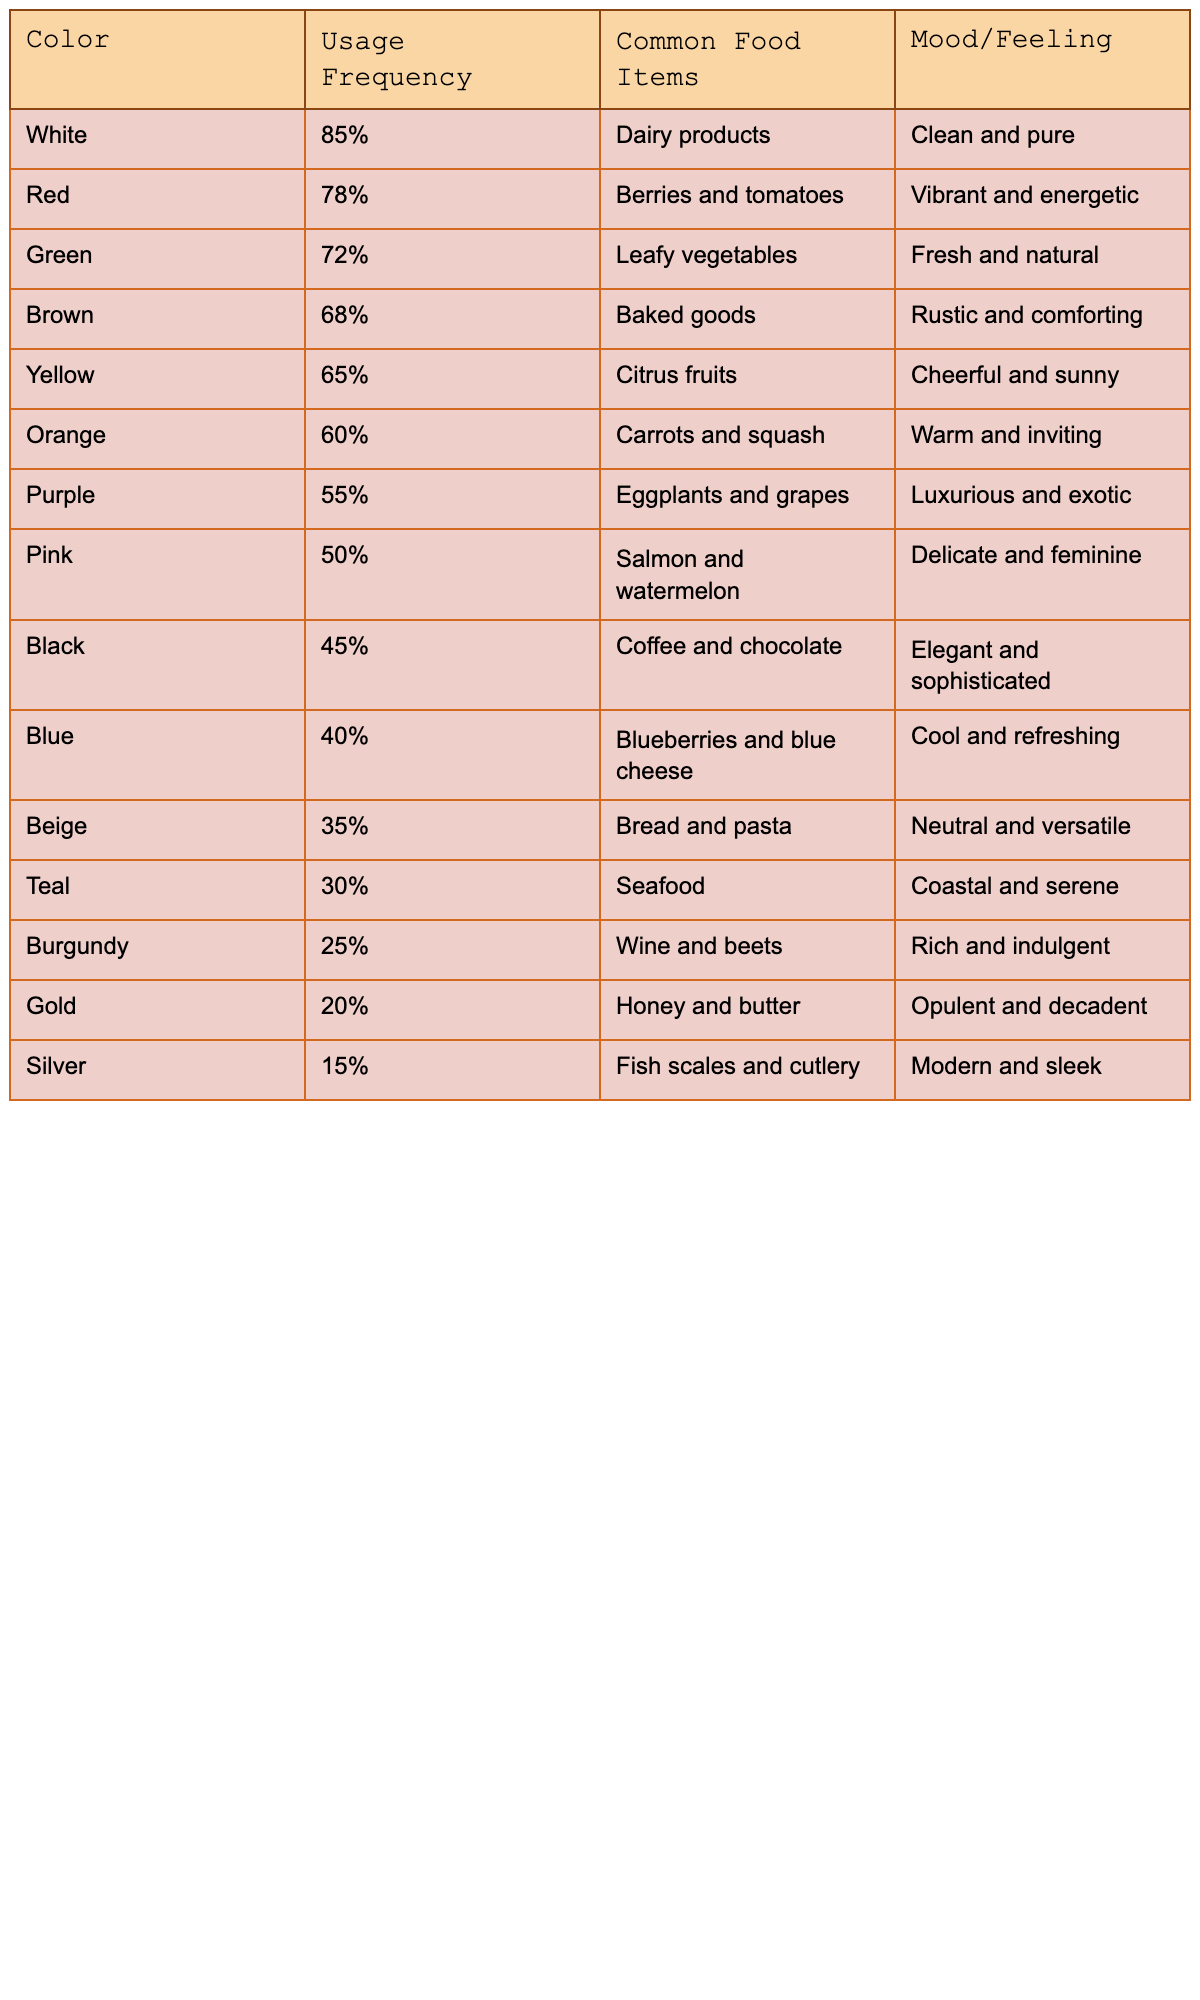What color has the highest usage frequency in food photography? By looking at the Usage Frequency column, White is at the top with 85%.
Answer: White Which two food colors are used more than 70% of the time in food photography? The Usage Frequency for Green is 72% and for Red is 78%, both are above 70%.
Answer: Green and Red Is there a color associated with a luxurious feeling that is also used frequently? Yes, Purple is associated with a luxurious feeling and has a usage frequency of 55%.
Answer: Yes What is the difference in usage frequency between Yellow and Orange? Yellow has a usage frequency of 65% and Orange has 60%. The difference is 65% - 60% = 5%.
Answer: 5% Which color is the least used in food photography? According to the table, Silver is the least used with a frequency of 15%.
Answer: Silver What is the average usage frequency of the top three colors: White, Red, and Green? The usage frequencies are 85%, 78%, and 72%. The average is (85 + 78 + 72) / 3 = 78.33%.
Answer: 78.33% What mood is associated with Black and how does its usage frequency compare to Bronze? Black evokes an elegant and sophisticated mood and has a frequency of 45%, while Burgundy, which might get confused with Bronze, has a frequency of 25%, making Black used more frequently.
Answer: More frequent If you consider the top five colors, what percentage do they collectively represent? The top five colors have usage frequencies of 85%, 78%, 72%, 68%, and 65%. The sum is 85 + 78 + 72 + 68 + 65 = 368%, which means they represent 368% collectively.
Answer: 368% How many colors have a usage frequency of less than 50%? Looking at the table, there are four colors—Blue, Beige, Teal, and Burgundy—that all have a usage frequency below 50%.
Answer: Four Which color has a cheerful and sunny mood, and what is its usage frequency? Yellow is associated with a cheerful and sunny mood, with a usage frequency of 65%.
Answer: Yellow, 65% 